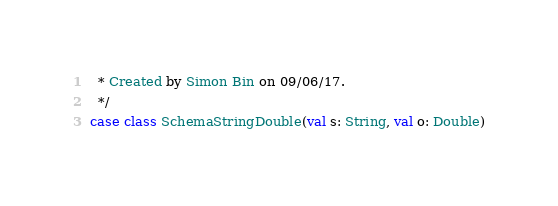Convert code to text. <code><loc_0><loc_0><loc_500><loc_500><_Scala_>  * Created by Simon Bin on 09/06/17.
  */
case class SchemaStringDouble(val s: String, val o: Double)
</code> 